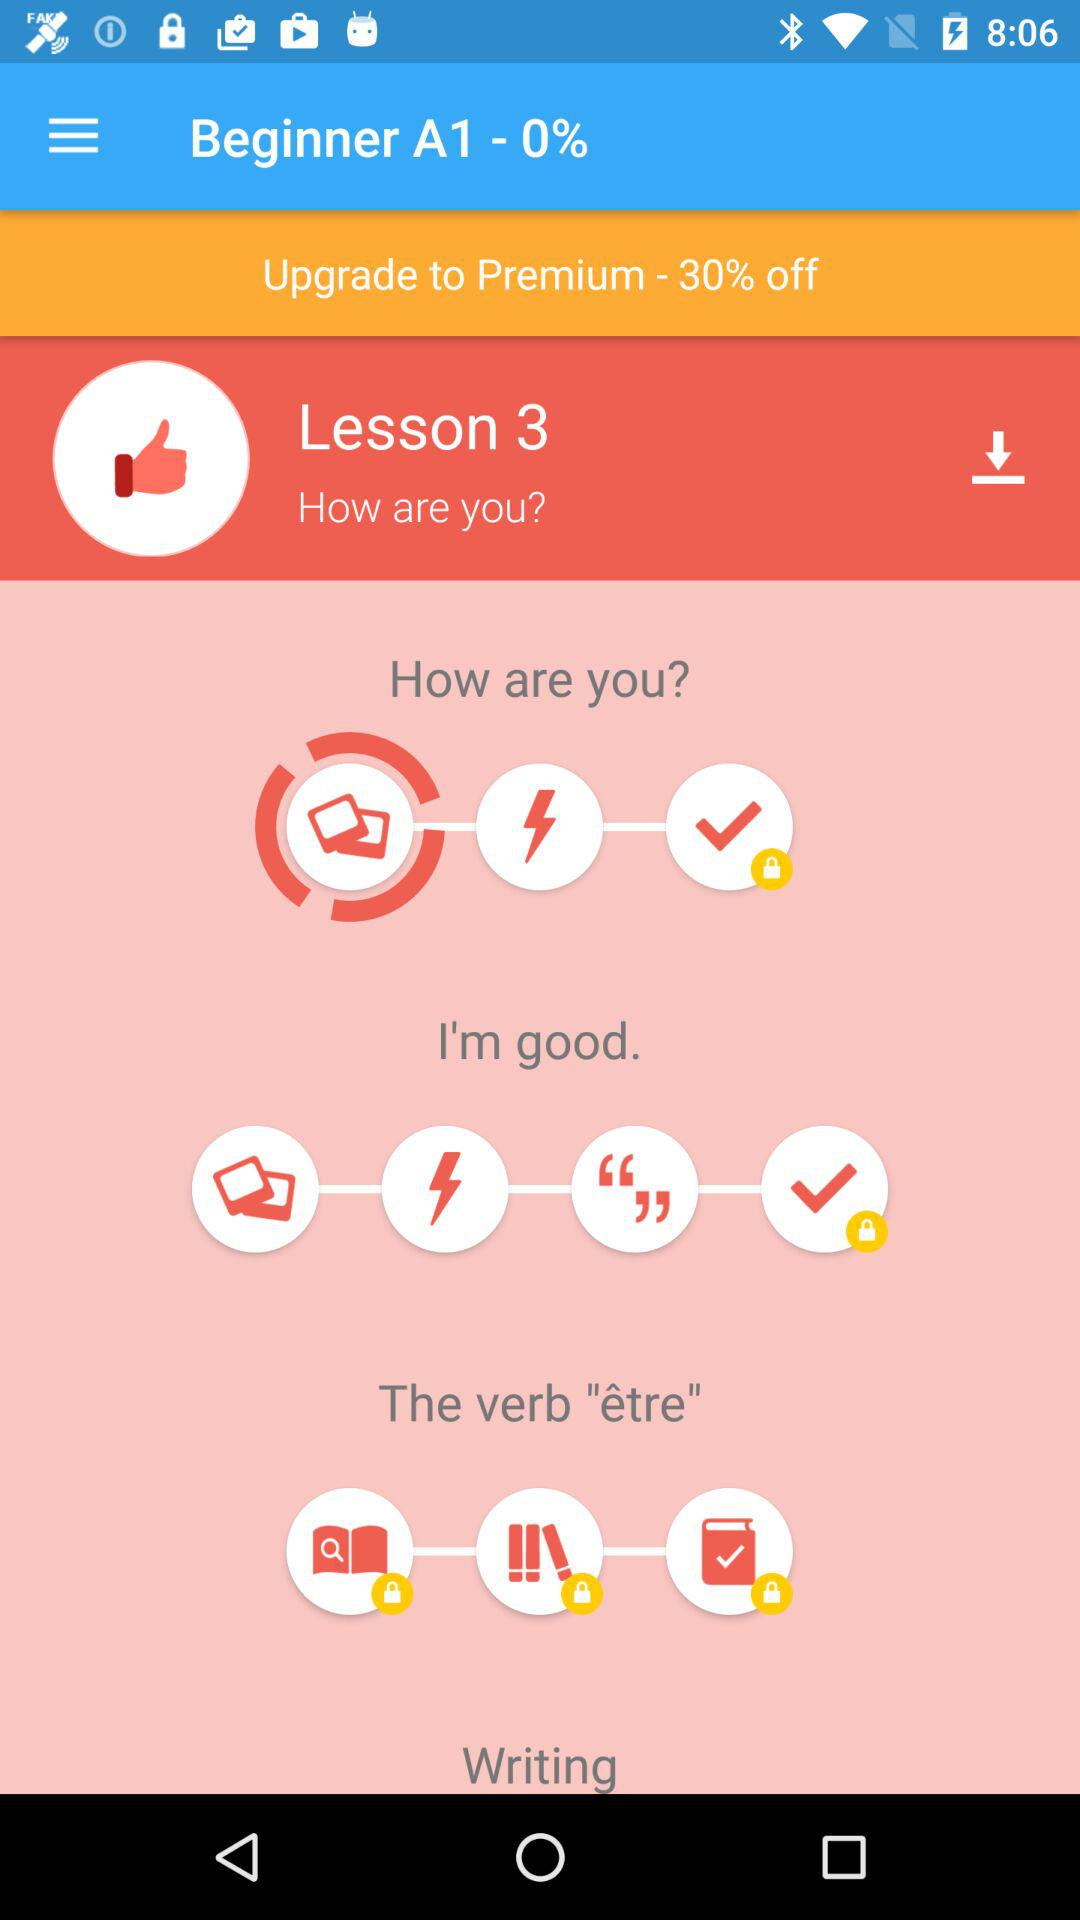How many lessons are available in the French course? Based on the image, there are several lessons visible within the French course, but only Lesson 3 titled 'How are you?' is fully displayed. The additional blank circles suggest that more lessons are available beyond what's presented. To get the total count of lessons, one would need to scroll through or access other sections of the course, which are not evident from the image. 